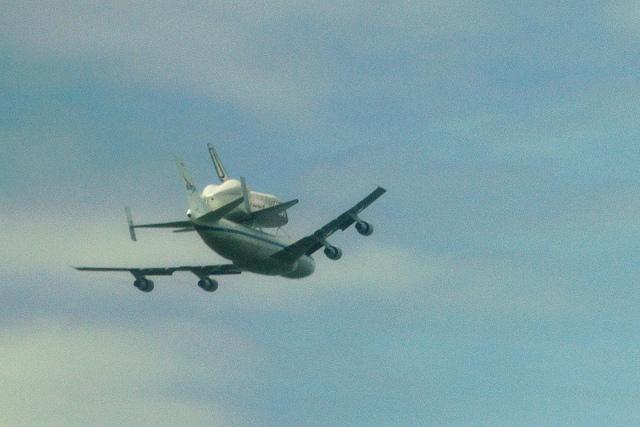How many turbine engines are visible in this picture?
Give a very brief answer. 4. How many planes pictured?
Be succinct. 2. What is the color of the plane?
Short answer required. White. How many wheels are there?
Short answer required. 0. Are these planes in motion?
Keep it brief. Yes. What is the airplane dropping off?
Quick response, please. Fuel. Is this a formation of fighter planes?
Be succinct. No. Is that plane piggy backing?
Answer briefly. Yes. Where are the planes at?
Give a very brief answer. Sky. Is this plane landing?
Give a very brief answer. No. What color are the planes?
Be succinct. White. Is there white steam coming out of plane?
Write a very short answer. No. How many people are in the plane?
Answer briefly. 5. How many engines on the plane?
Keep it brief. 4. What color is the plane?
Give a very brief answer. White. How many planes in the sky?
Give a very brief answer. 2. Does this look like a vintage picture?
Write a very short answer. No. Is this a black and white photo?
Be succinct. No. Are the plane's wheels up or down?
Quick response, please. Up. 